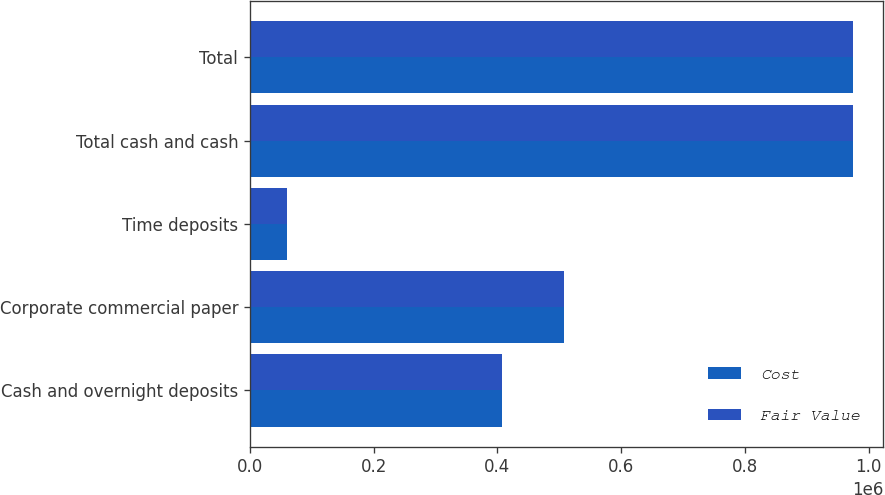<chart> <loc_0><loc_0><loc_500><loc_500><stacked_bar_chart><ecel><fcel>Cash and overnight deposits<fcel>Corporate commercial paper<fcel>Time deposits<fcel>Total cash and cash<fcel>Total<nl><fcel>Cost<fcel>406787<fcel>507777<fcel>59871<fcel>974435<fcel>974470<nl><fcel>Fair Value<fcel>406787<fcel>507889<fcel>59871<fcel>974547<fcel>974582<nl></chart> 